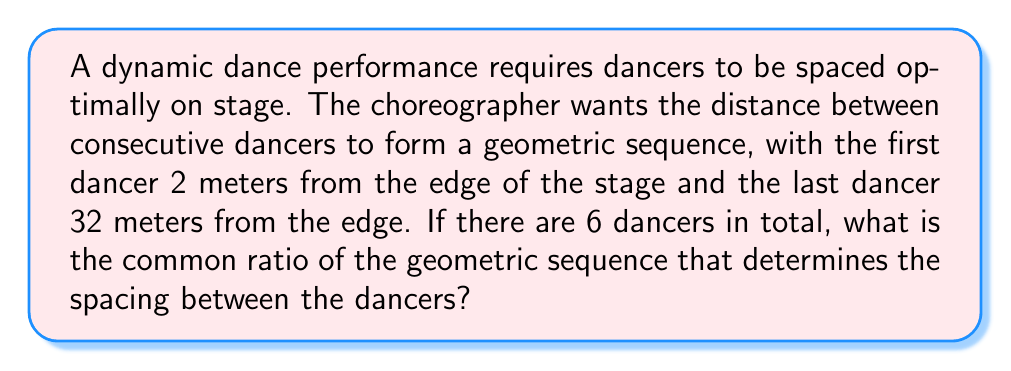Show me your answer to this math problem. Let's approach this step-by-step:

1) In a geometric sequence, each term is a constant multiple of the previous term. This constant is called the common ratio, which we'll denote as $r$.

2) Let's denote the positions of the dancers from the edge of the stage as $a_1, a_2, a_3, a_4, a_5, a_6$.

3) We're given that $a_1 = 2$ and $a_6 = 32$.

4) In a geometric sequence, we can express the nth term as:

   $a_n = a_1 \cdot r^{n-1}$

5) Using this formula for the 6th term:

   $a_6 = a_1 \cdot r^{6-1} = a_1 \cdot r^5$

6) Substituting the known values:

   $32 = 2 \cdot r^5$

7) Dividing both sides by 2:

   $16 = r^5$

8) Taking the fifth root of both sides:

   $r = \sqrt[5]{16} = 16^{\frac{1}{5}}$

9) This can be simplified to:

   $r = 2^{\frac{4}{5}} \approx 1.74$

Therefore, the common ratio of the geometric sequence is $2^{\frac{4}{5}}$.
Answer: $2^{\frac{4}{5}}$ 